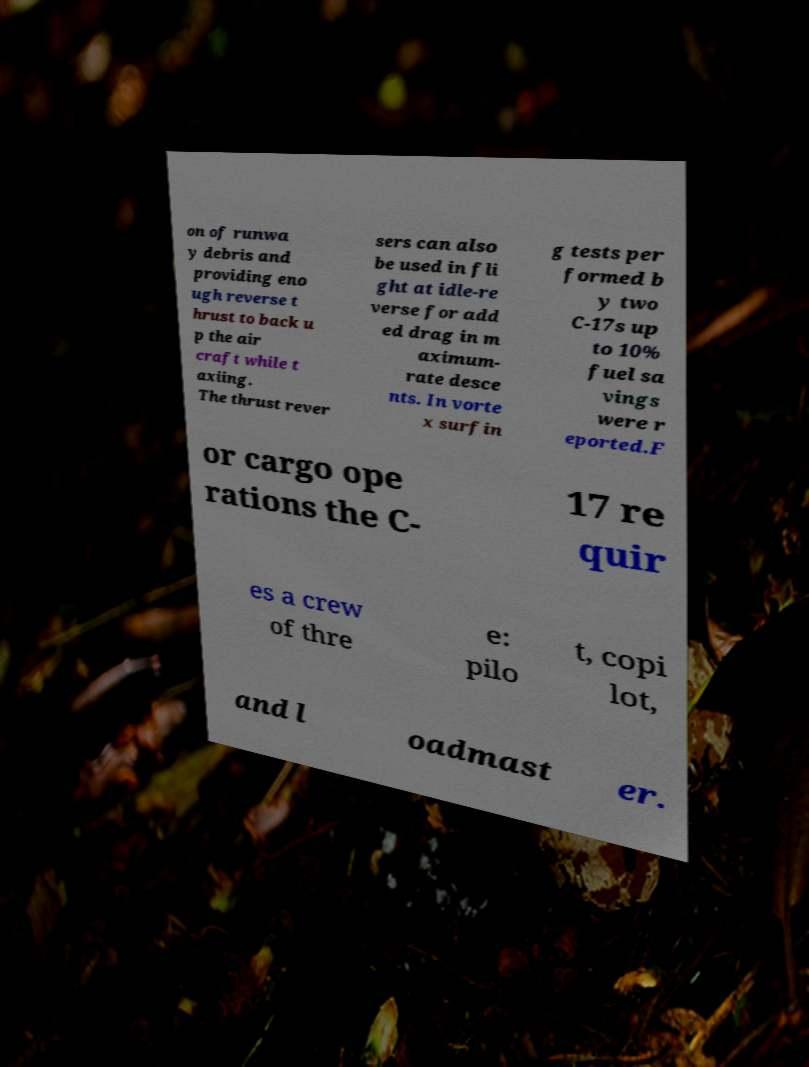Can you read and provide the text displayed in the image?This photo seems to have some interesting text. Can you extract and type it out for me? on of runwa y debris and providing eno ugh reverse t hrust to back u p the air craft while t axiing. The thrust rever sers can also be used in fli ght at idle-re verse for add ed drag in m aximum- rate desce nts. In vorte x surfin g tests per formed b y two C-17s up to 10% fuel sa vings were r eported.F or cargo ope rations the C- 17 re quir es a crew of thre e: pilo t, copi lot, and l oadmast er. 